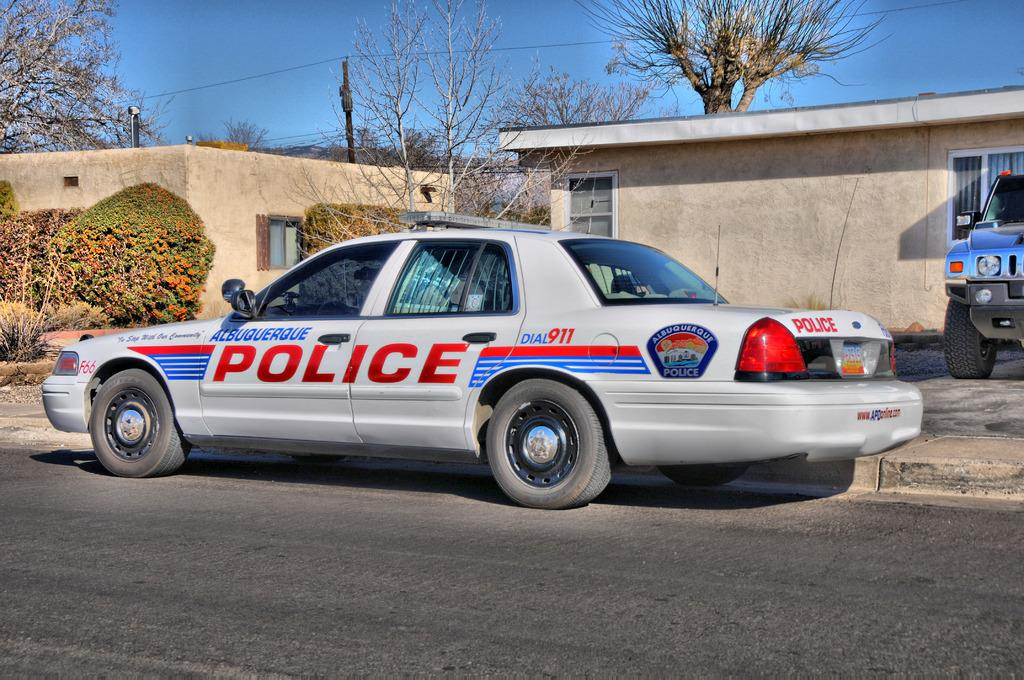<image>
Write a terse but informative summary of the picture. An Alburquerque Polic car sits in front of a house. 